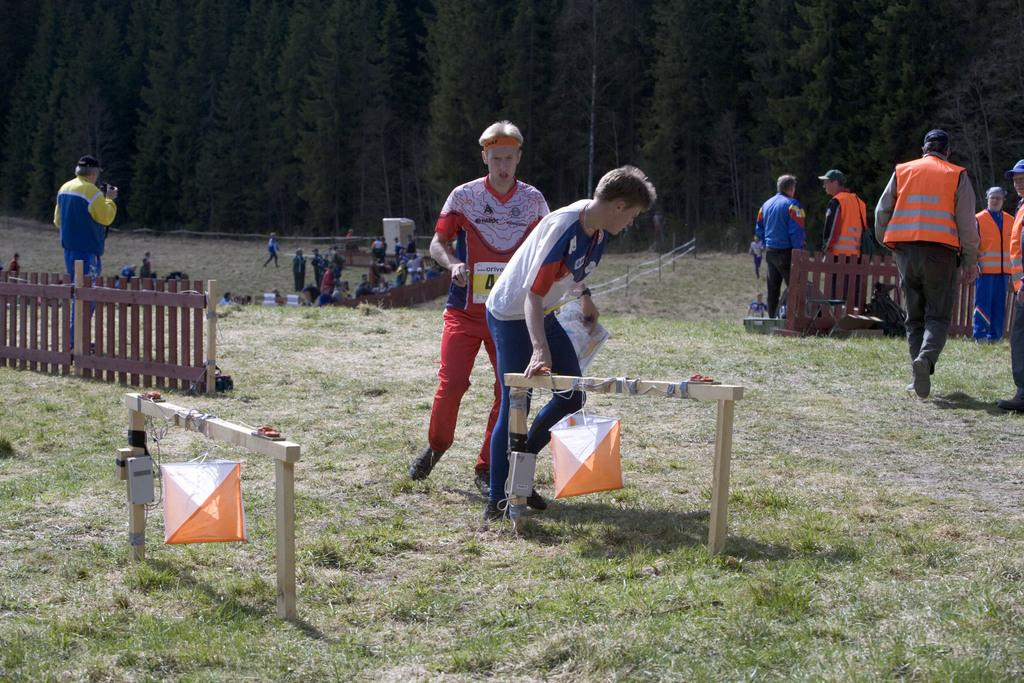What is happening on the ground in the image? There are people on the ground in the image. What type of barrier is present in the image? There is a fence visible in the image. What else can be seen in the image besides people and the fence? There are other objects visible in the image. What type of vegetation is visible at the top of the image? Trees are visible at the top of the image. What type of representative is present in the image? There is no representative present in the image; it only shows people, a fence, other objects, and trees. What type of army is visible in the image? There is no army present in the image; it only shows people, a fence, other objects, and trees. 